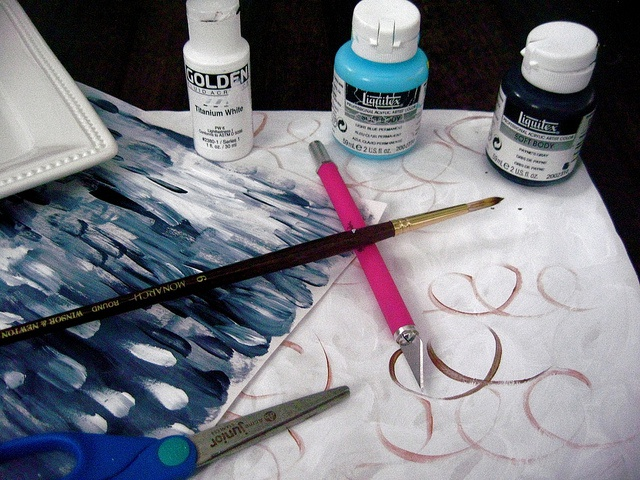Describe the objects in this image and their specific colors. I can see bottle in gray, black, darkgray, and lightgray tones, scissors in gray, navy, black, and teal tones, bottle in gray, darkgray, lightgray, and teal tones, bottle in gray, darkgray, lightgray, and black tones, and knife in gray, purple, brown, and darkgray tones in this image. 